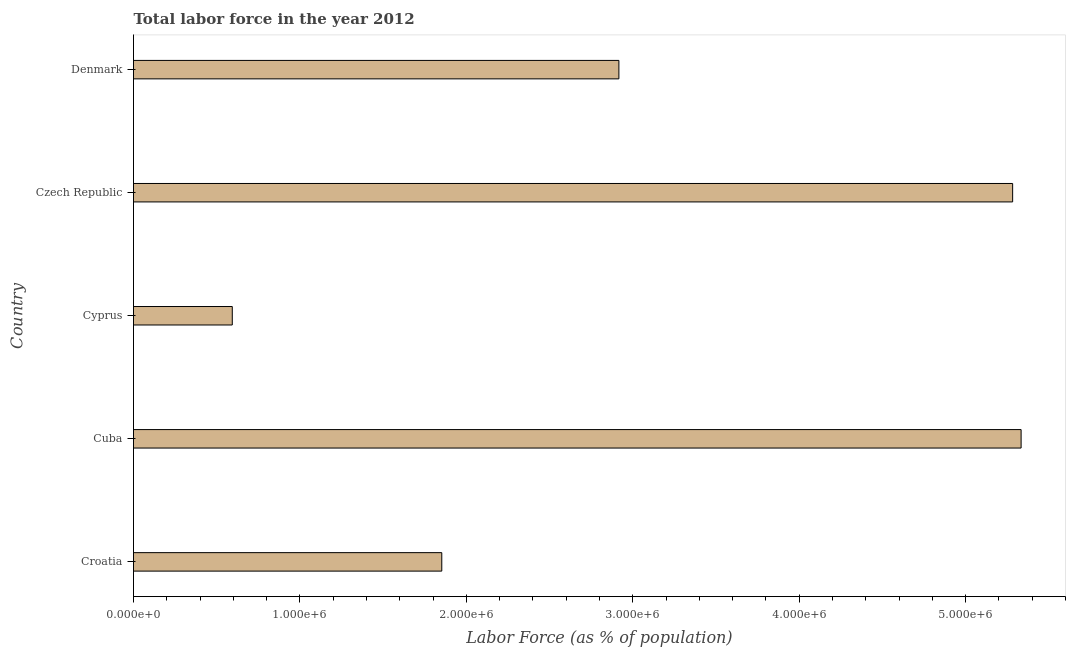Does the graph contain any zero values?
Your answer should be compact. No. What is the title of the graph?
Keep it short and to the point. Total labor force in the year 2012. What is the label or title of the X-axis?
Your response must be concise. Labor Force (as % of population). What is the total labor force in Cuba?
Provide a short and direct response. 5.33e+06. Across all countries, what is the maximum total labor force?
Keep it short and to the point. 5.33e+06. Across all countries, what is the minimum total labor force?
Make the answer very short. 5.94e+05. In which country was the total labor force maximum?
Keep it short and to the point. Cuba. In which country was the total labor force minimum?
Offer a very short reply. Cyprus. What is the sum of the total labor force?
Keep it short and to the point. 1.60e+07. What is the difference between the total labor force in Croatia and Cyprus?
Your answer should be very brief. 1.26e+06. What is the average total labor force per country?
Provide a short and direct response. 3.20e+06. What is the median total labor force?
Your answer should be compact. 2.92e+06. In how many countries, is the total labor force greater than 5000000 %?
Offer a very short reply. 2. What is the ratio of the total labor force in Cuba to that in Denmark?
Your answer should be compact. 1.83. What is the difference between the highest and the second highest total labor force?
Your answer should be compact. 5.09e+04. What is the difference between the highest and the lowest total labor force?
Provide a short and direct response. 4.74e+06. In how many countries, is the total labor force greater than the average total labor force taken over all countries?
Give a very brief answer. 2. Are all the bars in the graph horizontal?
Give a very brief answer. Yes. How many countries are there in the graph?
Your answer should be compact. 5. What is the difference between two consecutive major ticks on the X-axis?
Provide a succinct answer. 1.00e+06. Are the values on the major ticks of X-axis written in scientific E-notation?
Offer a very short reply. Yes. What is the Labor Force (as % of population) of Croatia?
Your answer should be compact. 1.85e+06. What is the Labor Force (as % of population) of Cuba?
Give a very brief answer. 5.33e+06. What is the Labor Force (as % of population) in Cyprus?
Keep it short and to the point. 5.94e+05. What is the Labor Force (as % of population) of Czech Republic?
Offer a terse response. 5.28e+06. What is the Labor Force (as % of population) of Denmark?
Offer a very short reply. 2.92e+06. What is the difference between the Labor Force (as % of population) in Croatia and Cuba?
Your answer should be compact. -3.48e+06. What is the difference between the Labor Force (as % of population) in Croatia and Cyprus?
Offer a very short reply. 1.26e+06. What is the difference between the Labor Force (as % of population) in Croatia and Czech Republic?
Offer a very short reply. -3.43e+06. What is the difference between the Labor Force (as % of population) in Croatia and Denmark?
Offer a terse response. -1.06e+06. What is the difference between the Labor Force (as % of population) in Cuba and Cyprus?
Provide a short and direct response. 4.74e+06. What is the difference between the Labor Force (as % of population) in Cuba and Czech Republic?
Your response must be concise. 5.09e+04. What is the difference between the Labor Force (as % of population) in Cuba and Denmark?
Offer a terse response. 2.42e+06. What is the difference between the Labor Force (as % of population) in Cyprus and Czech Republic?
Provide a succinct answer. -4.69e+06. What is the difference between the Labor Force (as % of population) in Cyprus and Denmark?
Provide a short and direct response. -2.32e+06. What is the difference between the Labor Force (as % of population) in Czech Republic and Denmark?
Make the answer very short. 2.37e+06. What is the ratio of the Labor Force (as % of population) in Croatia to that in Cuba?
Keep it short and to the point. 0.35. What is the ratio of the Labor Force (as % of population) in Croatia to that in Cyprus?
Your answer should be very brief. 3.12. What is the ratio of the Labor Force (as % of population) in Croatia to that in Czech Republic?
Offer a very short reply. 0.35. What is the ratio of the Labor Force (as % of population) in Croatia to that in Denmark?
Provide a short and direct response. 0.64. What is the ratio of the Labor Force (as % of population) in Cuba to that in Cyprus?
Give a very brief answer. 8.99. What is the ratio of the Labor Force (as % of population) in Cuba to that in Denmark?
Ensure brevity in your answer.  1.83. What is the ratio of the Labor Force (as % of population) in Cyprus to that in Czech Republic?
Keep it short and to the point. 0.11. What is the ratio of the Labor Force (as % of population) in Cyprus to that in Denmark?
Your response must be concise. 0.2. What is the ratio of the Labor Force (as % of population) in Czech Republic to that in Denmark?
Your response must be concise. 1.81. 